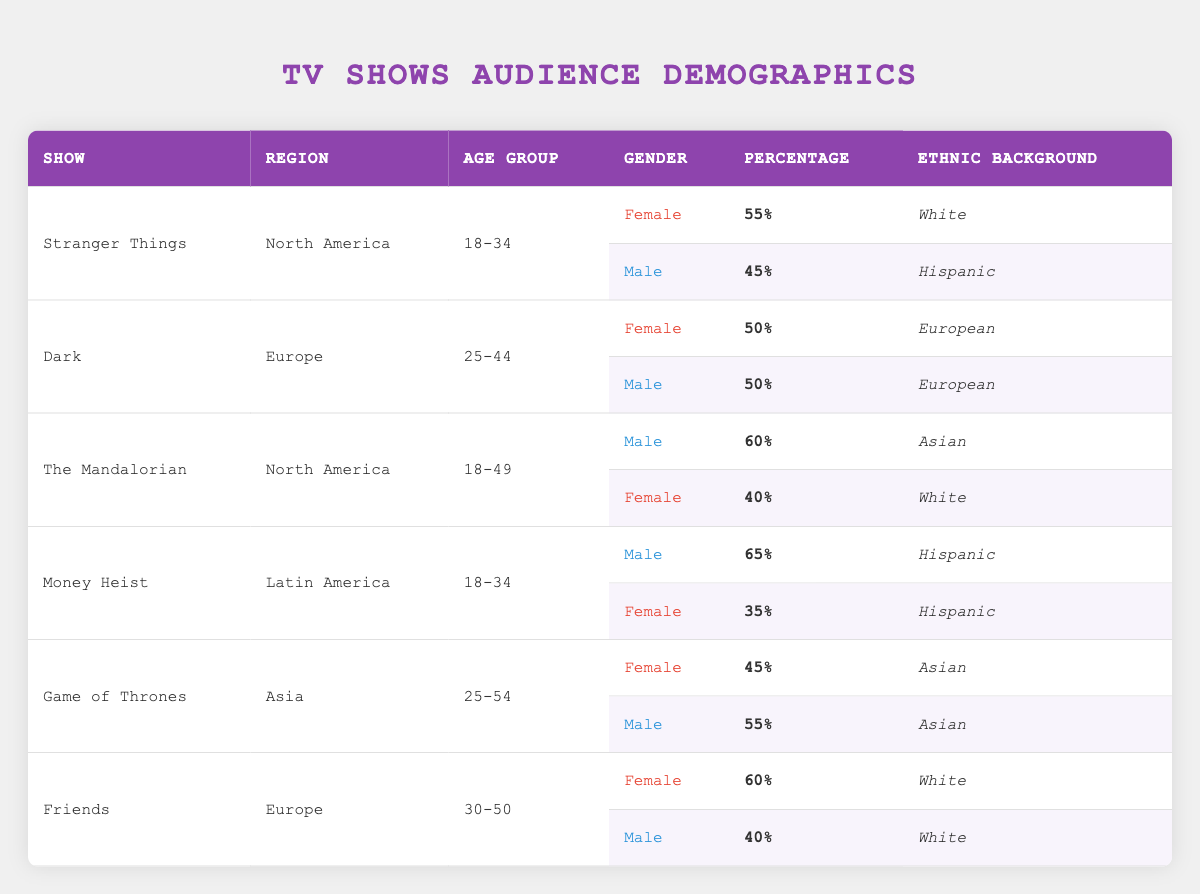What percentage of the audience for "The Mandalorian" in North America is male? The table shows "The Mandalorian" under the North America region. The male audience percentage for this show is given as 60%.
Answer: 60% What is the ethnic background of the majority audience for "Stranger Things" in North America? In North America, "Stranger Things" has a female audience percentage of 55%, which has an ethnic background of White. This is the highest percentage, indicating that the majority audience is White.
Answer: White Is the male audience for "Money Heist" greater than the female audience in Latin America? The male audience for "Money Heist" in Latin America is 65%, and the female audience is 35%. Since 65% is greater than 35%, the statement is true.
Answer: Yes What is the total audience percentage for both genders of "Game of Thrones" in Asia? The percentages for "Game of Thrones" in Asia are 45% female and 55% male. Adding these together gives 45% + 55% = 100%.
Answer: 100% In which region does "Friends" have a higher female audience percentage, Europe or Asia? The table only provides audience demographics for "Friends" in Europe, where the female audience is 60%. There are no demographic data for "Friends" in Asia, making direct comparison impossible.
Answer: N/A Which show has a similar audience percentage (50%) for both genders in Europe? The show "Dark" in Europe has 50% for both female and male audiences, making it the only show with this characteristic in the provided data.
Answer: Dark What is the percentage difference of the male audience between "Game of Thrones" and "Stranger Things" in Asia and North America respectively? In Asia, "Game of Thrones" has a male audience percentage of 55%. In North America, "Stranger Things" has a male audience percentage of 45%. The difference is calculated as 55% - 45% = 10%.
Answer: 10% Which ethnic background has the lowest representation among the audience for "The Mandalorian" in North America? The female audience for "The Mandalorian" has an ethnic background of White at 40%, while the male audience has an Asian background at 60%. Since 40% is lower, White has the least representation.
Answer: White What is the gender distribution of the audience for "Dark" in Europe? The gender distribution for "Dark" in Europe is 50% female and 50% male, as specified in the table for that show and region.
Answer: 50% female and 50% male Are there any ethnic backgrounds represented among the audience percentages for "Money Heist" in Latin America? Yes, both genders of the "Money Heist" audience in Latin America are identified as Hispanic, confirming representation of this ethnic background.
Answer: Yes 